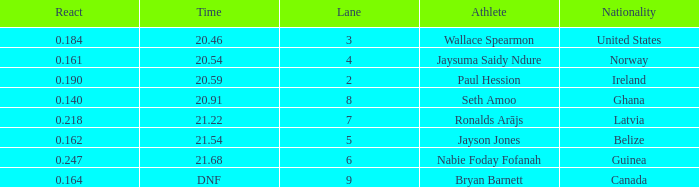What is the lowest lane when react is more than 0.164 and the nationality is guinea? 6.0. 